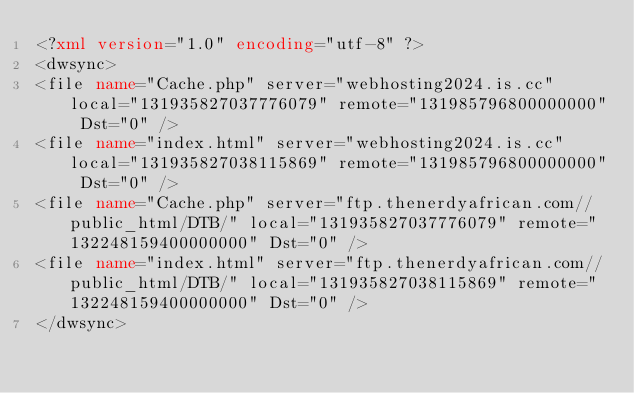Convert code to text. <code><loc_0><loc_0><loc_500><loc_500><_XML_><?xml version="1.0" encoding="utf-8" ?>
<dwsync>
<file name="Cache.php" server="webhosting2024.is.cc" local="131935827037776079" remote="131985796800000000" Dst="0" />
<file name="index.html" server="webhosting2024.is.cc" local="131935827038115869" remote="131985796800000000" Dst="0" />
<file name="Cache.php" server="ftp.thenerdyafrican.com//public_html/DTB/" local="131935827037776079" remote="132248159400000000" Dst="0" />
<file name="index.html" server="ftp.thenerdyafrican.com//public_html/DTB/" local="131935827038115869" remote="132248159400000000" Dst="0" />
</dwsync></code> 